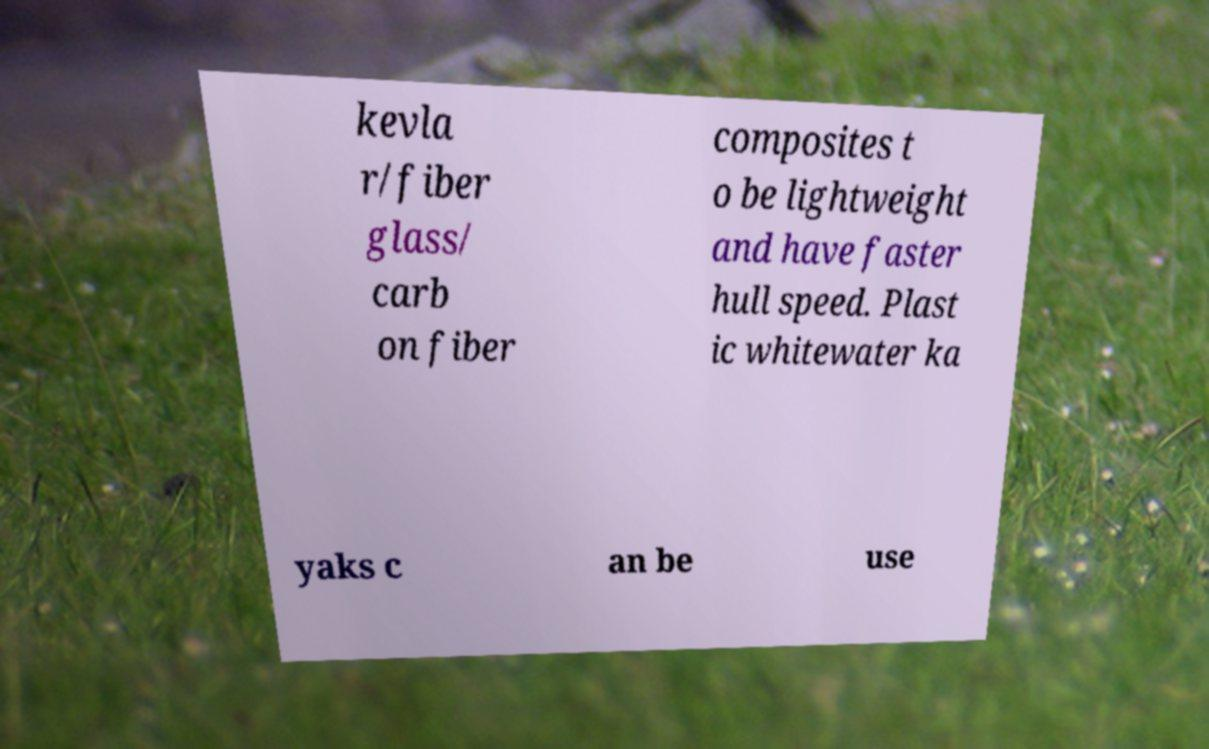For documentation purposes, I need the text within this image transcribed. Could you provide that? kevla r/fiber glass/ carb on fiber composites t o be lightweight and have faster hull speed. Plast ic whitewater ka yaks c an be use 